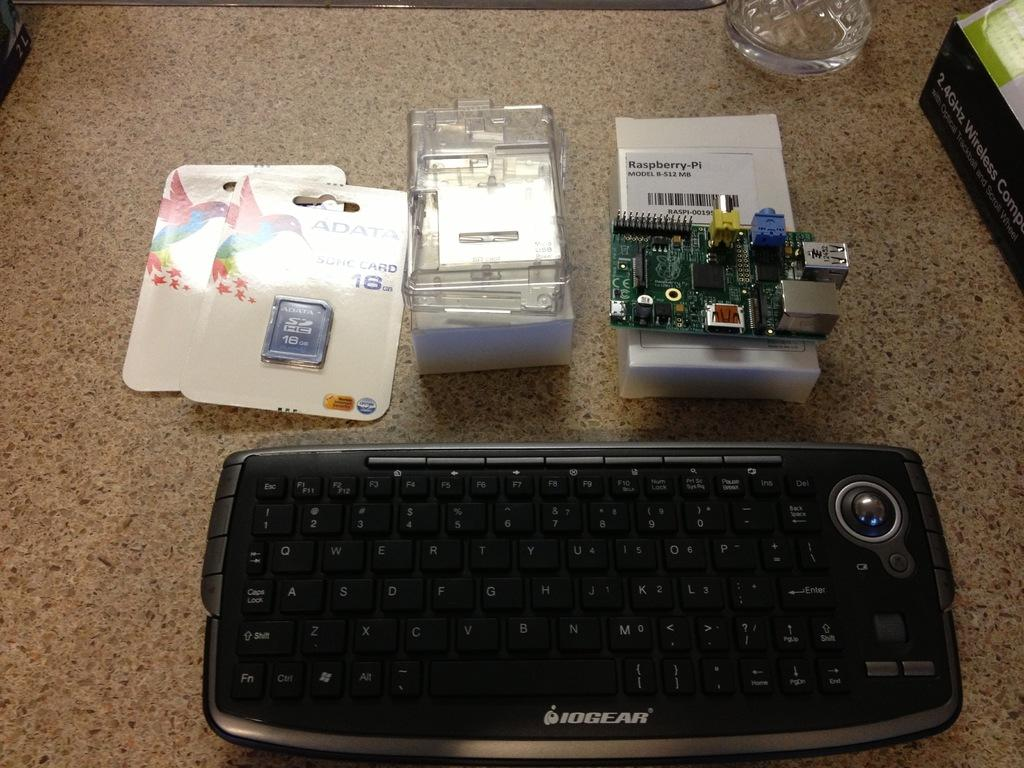<image>
Render a clear and concise summary of the photo. Two SDHC cards with at least one with 16GB of space. 